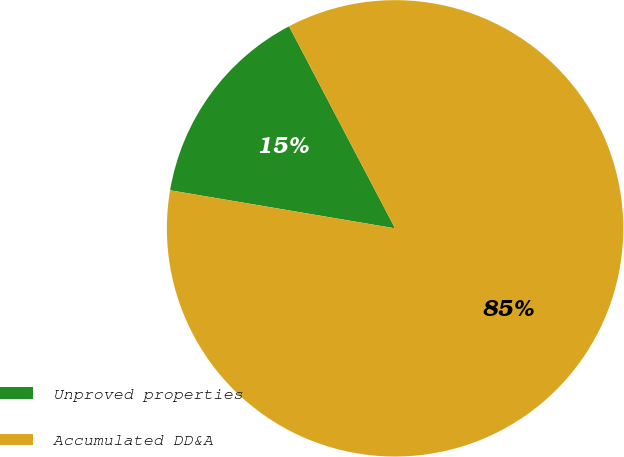<chart> <loc_0><loc_0><loc_500><loc_500><pie_chart><fcel>Unproved properties<fcel>Accumulated DD&A<nl><fcel>14.64%<fcel>85.36%<nl></chart> 